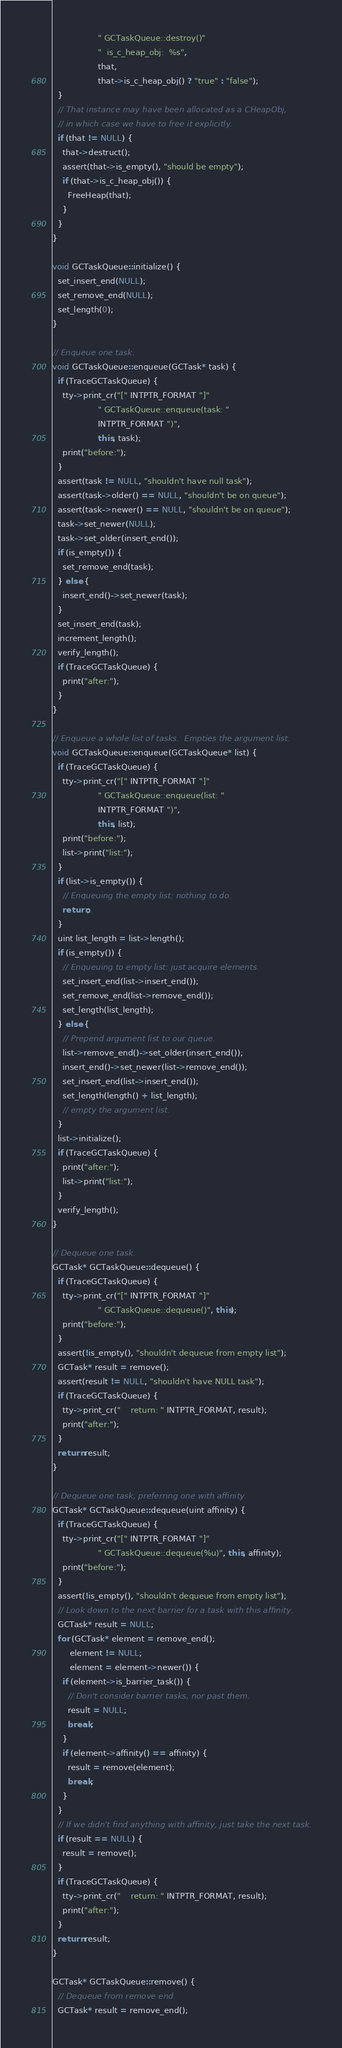Convert code to text. <code><loc_0><loc_0><loc_500><loc_500><_C++_>                  " GCTaskQueue::destroy()"
                  "  is_c_heap_obj:  %s",
                  that,
                  that->is_c_heap_obj() ? "true" : "false");
  }
  // That instance may have been allocated as a CHeapObj,
  // in which case we have to free it explicitly.
  if (that != NULL) {
    that->destruct();
    assert(that->is_empty(), "should be empty");
    if (that->is_c_heap_obj()) {
      FreeHeap(that);
    }
  }
}

void GCTaskQueue::initialize() {
  set_insert_end(NULL);
  set_remove_end(NULL);
  set_length(0);
}

// Enqueue one task.
void GCTaskQueue::enqueue(GCTask* task) {
  if (TraceGCTaskQueue) {
    tty->print_cr("[" INTPTR_FORMAT "]"
                  " GCTaskQueue::enqueue(task: "
                  INTPTR_FORMAT ")",
                  this, task);
    print("before:");
  }
  assert(task != NULL, "shouldn't have null task");
  assert(task->older() == NULL, "shouldn't be on queue");
  assert(task->newer() == NULL, "shouldn't be on queue");
  task->set_newer(NULL);
  task->set_older(insert_end());
  if (is_empty()) {
    set_remove_end(task);
  } else {
    insert_end()->set_newer(task);
  }
  set_insert_end(task);
  increment_length();
  verify_length();
  if (TraceGCTaskQueue) {
    print("after:");
  }
}

// Enqueue a whole list of tasks.  Empties the argument list.
void GCTaskQueue::enqueue(GCTaskQueue* list) {
  if (TraceGCTaskQueue) {
    tty->print_cr("[" INTPTR_FORMAT "]"
                  " GCTaskQueue::enqueue(list: "
                  INTPTR_FORMAT ")",
                  this, list);
    print("before:");
    list->print("list:");
  }
  if (list->is_empty()) {
    // Enqueuing the empty list: nothing to do.
    return;
  }
  uint list_length = list->length();
  if (is_empty()) {
    // Enqueuing to empty list: just acquire elements.
    set_insert_end(list->insert_end());
    set_remove_end(list->remove_end());
    set_length(list_length);
  } else {
    // Prepend argument list to our queue.
    list->remove_end()->set_older(insert_end());
    insert_end()->set_newer(list->remove_end());
    set_insert_end(list->insert_end());
    set_length(length() + list_length);
    // empty the argument list.
  }
  list->initialize();
  if (TraceGCTaskQueue) {
    print("after:");
    list->print("list:");
  }
  verify_length();
}

// Dequeue one task.
GCTask* GCTaskQueue::dequeue() {
  if (TraceGCTaskQueue) {
    tty->print_cr("[" INTPTR_FORMAT "]"
                  " GCTaskQueue::dequeue()", this);
    print("before:");
  }
  assert(!is_empty(), "shouldn't dequeue from empty list");
  GCTask* result = remove();
  assert(result != NULL, "shouldn't have NULL task");
  if (TraceGCTaskQueue) {
    tty->print_cr("    return: " INTPTR_FORMAT, result);
    print("after:");
  }
  return result;
}

// Dequeue one task, preferring one with affinity.
GCTask* GCTaskQueue::dequeue(uint affinity) {
  if (TraceGCTaskQueue) {
    tty->print_cr("[" INTPTR_FORMAT "]"
                  " GCTaskQueue::dequeue(%u)", this, affinity);
    print("before:");
  }
  assert(!is_empty(), "shouldn't dequeue from empty list");
  // Look down to the next barrier for a task with this affinity.
  GCTask* result = NULL;
  for (GCTask* element = remove_end();
       element != NULL;
       element = element->newer()) {
    if (element->is_barrier_task()) {
      // Don't consider barrier tasks, nor past them.
      result = NULL;
      break;
    }
    if (element->affinity() == affinity) {
      result = remove(element);
      break;
    }
  }
  // If we didn't find anything with affinity, just take the next task.
  if (result == NULL) {
    result = remove();
  }
  if (TraceGCTaskQueue) {
    tty->print_cr("    return: " INTPTR_FORMAT, result);
    print("after:");
  }
  return result;
}

GCTask* GCTaskQueue::remove() {
  // Dequeue from remove end.
  GCTask* result = remove_end();</code> 